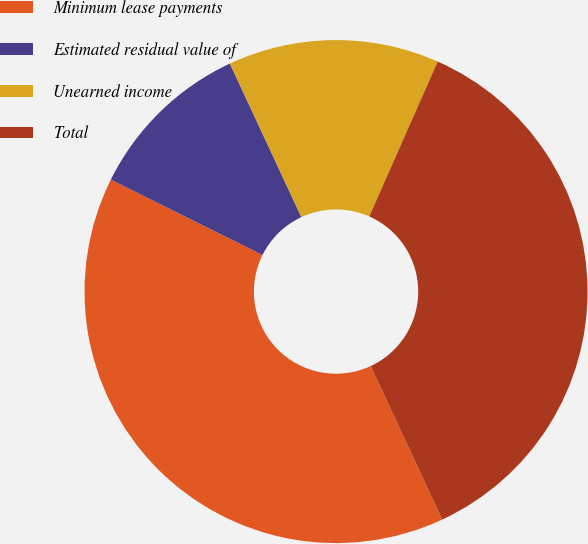Convert chart to OTSL. <chart><loc_0><loc_0><loc_500><loc_500><pie_chart><fcel>Minimum lease payments<fcel>Estimated residual value of<fcel>Unearned income<fcel>Total<nl><fcel>39.28%<fcel>10.72%<fcel>13.56%<fcel>36.44%<nl></chart> 